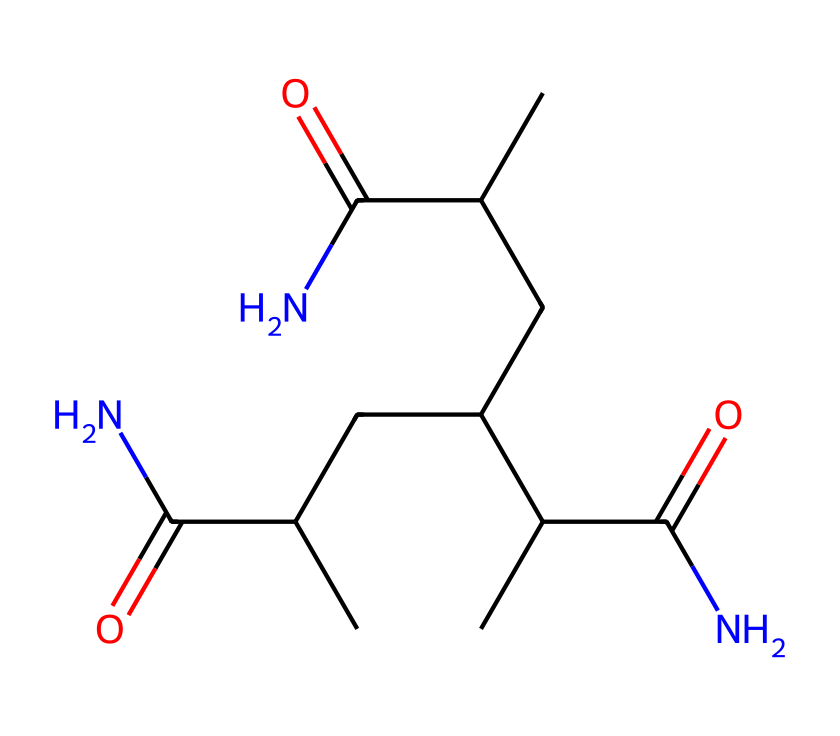What is the name of this chemical? The SMILES representation corresponds to polyacrylamide. The presence of amide (C(=O)N) groups and the long carbon chain structure indicates it is a polymer typically associated with hair gels.
Answer: polyacrylamide How many carbon atoms are in this molecule? By analyzing the SMILES structure, we count a total of 11 carbon atoms. Each 'C' in the SMILES indicates a carbon atom, and the analysis of the structure confirms it.
Answer: 11 What type of solution does this chemical typically form? Polyacrylamide forms a gel-like solution when dissolved in water, demonstrating its properties as a non-Newtonian fluid. The arrangement of its molecules allows it to behave differently under various stresses.
Answer: gel-like solution What functional groups are present in this molecule? The molecule contains amide functional groups, represented by the segments (C(=O)N) in the SMILES notation. These groups are responsible for the properties of polyacrylamide.
Answer: amide Why does this chemical exhibit non-Newtonian behavior? Polyacrylamide's long chain structure contributes to its entanglement and network formation when dissolved in water. These characteristics allow it to change viscosity under shear stress, a key feature of non-Newtonian fluids.
Answer: entanglement What is the primary application of polyacrylamide in hair gels? Polyacrylamide serves as a thickening agent in hair gels, providing texture and control over hair styling while maintaining a non-greasy feel.
Answer: thickening agent 